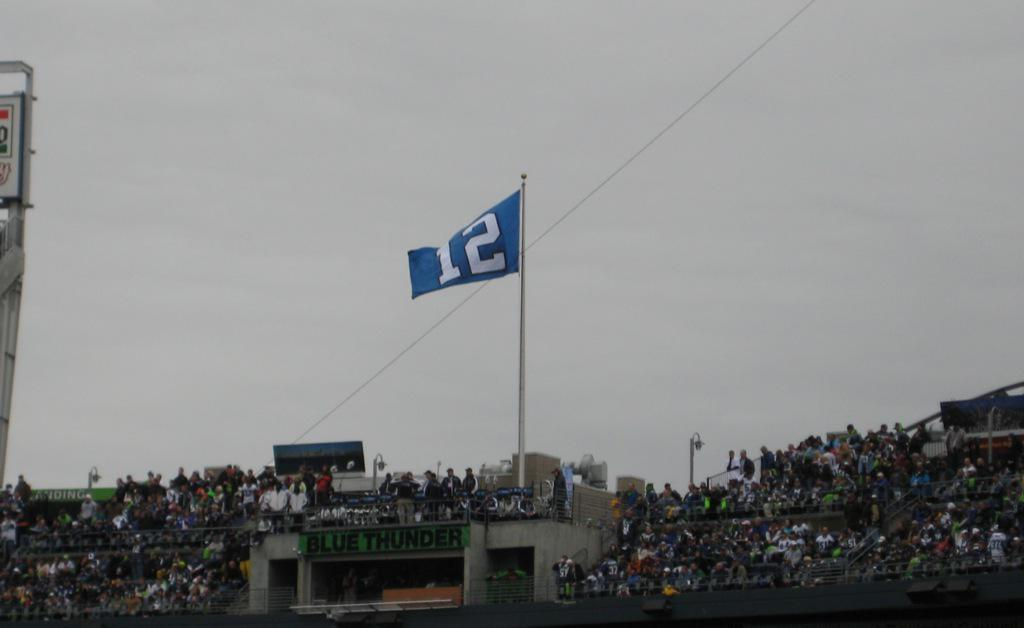<image>
Share a concise interpretation of the image provided. A blue flag with the number 12 on it in white flies above the blue thunder stadium which is packed with spectators. 